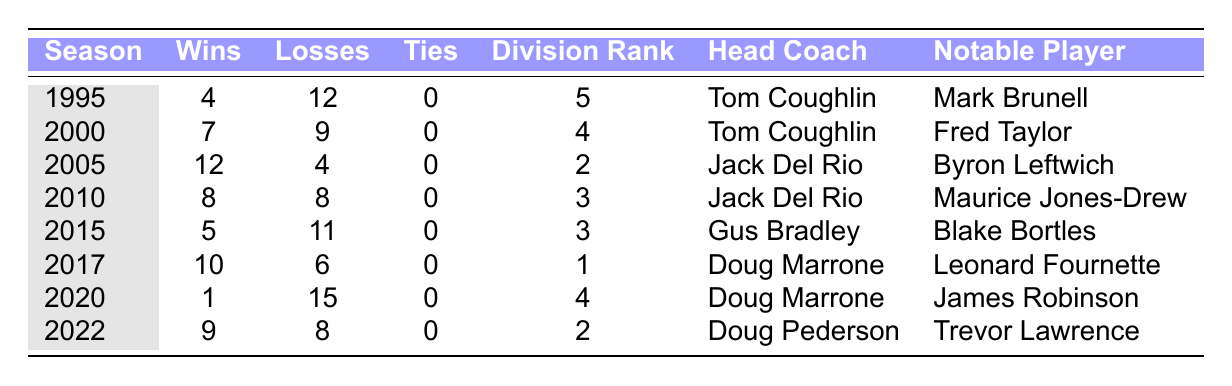What was the Jacksonville Jaguars' win-loss record in 1995? The record for the 1995 season is listed in the table as 4 wins and 12 losses.
Answer: 4 wins, 12 losses Who was the head coach in 2017? The table shows that Doug Marrone was the head coach during the 2017 season.
Answer: Doug Marrone How many seasons did the Jaguars have more than 10 wins? The years 2005 and 2017 are the only two seasons where the Jaguars had 12 and 10 wins, respectively, totaling 2 seasons.
Answer: 2 seasons What was the notable player for the 2020 season? The table indicates that James Robinson was the notable player in the 2020 season.
Answer: James Robinson In which season did they have their worst record? The table highlights that 2020 was their worst record with 1 win and 15 losses.
Answer: 2020 What is the average number of wins the team had between 1995 and 2022? The total number of wins from the table is 4 + 7 + 12 + 8 + 5 + 10 + 1 + 9 = 56. There are 8 seasons, so the average is 56/8 = 7.
Answer: 7 Which head coach had the most successful season based on Wins? Jack Del Rio had the most successful season in 2005 with 12 wins, as seen in the table.
Answer: Jack Del Rio Did the Jaguars ever finish first in their division? According to the table, the highest division rank they achieved was 1st in 2017, confirming that they did finish first in their division.
Answer: Yes Compare the win-loss records of the seasons 2010 and 2015. Which season had a better record? In 2010, the Jaguars had 8 wins and 8 losses. In 2015, they had 5 wins and 11 losses. Since 8 wins and 8 losses is better than 5 wins and 11 losses, 2010 is better.
Answer: 2010 had a better record How many years did the Jaguars have a winning season from 1995 to 2022? The years with more wins than losses (winning seasons) are 2005, 2010, 2017, and 2022, totaling 4 years.
Answer: 4 years 